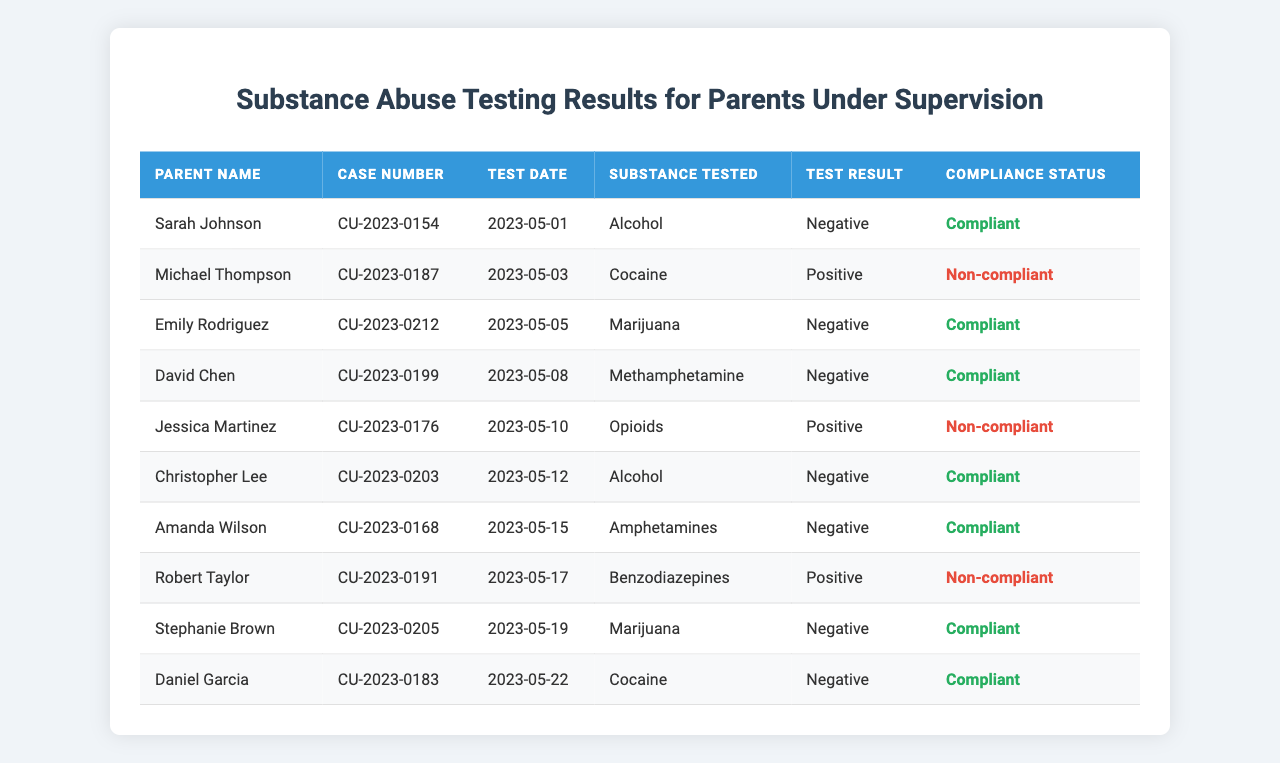What is the total number of compliant parents in the testing results? By reviewing the Compliance Status column, I will count the instances of "Compliant." There are 7 parents marked as compliant.
Answer: 7 How many parents had a positive test result for opioids? I will check the Test Result column for the substance "Opioids." Only Jessica Martinez had a positive test result for opioids, making the count one.
Answer: 1 What substance was tested most frequently among the parents? To determine the most frequently tested substance, I will tally each unique substance found in the Substance Tested column. The substances tested are Alcohol, Cocaine, Marijuana, Methamphetamine, Opioids, and Amphetamines. The most frequently appearing substances are Alcohol and Marijuana, each tested twice.
Answer: Alcohol and Marijuana What percentage of test results were negative? I will count the total number of tests (10) and the number of negative results (8). The percentage is calculated as (8/10) * 100 = 80%.
Answer: 80% Was there any parent who was both non-compliant and tested for cocaine? I will check the entries for Cocaine in the Substance Tested column and see the Compliance Status. Michael Thompson has a positive test result for cocaine and is marked as non-compliant.
Answer: Yes How many total positive test results were recorded? I need to check the Test Result column for occurrences of "Positive." There are 3 positive test results overall.
Answer: 3 What is the average number of parents who are compliant for each substance tested? I will count the total number of unique substances (6) and the number of compliant parents (7). Then, I divide the compliant count by the number of substances: 7/6 ≈ 1.17.
Answer: 1.17 Which parent had the last test date, and what was the test result? I will check all Test Dates and find the most recent one. Daniel Garcia had the last test date on 2023-05-22 with a test result of negative.
Answer: Daniel Garcia, Negative How many different substances were tested in total? By listing the unique substances from the Substance Tested column (Alcohol, Cocaine, Marijuana, Methamphetamine, Opioids, Amphetamines, Benzodiazepines), I find there are 7 different substances tested.
Answer: 7 Were all compliant parents tested for substances that had negative results? I will check each compliant parent’s test results to ensure they are all negative. All compliant parents (Sarah Johnson, Emily Rodriguez, David Chen, Christopher Lee, Amanda Wilson, Stephanie Brown, Daniel Garcia) have negative results.
Answer: Yes 